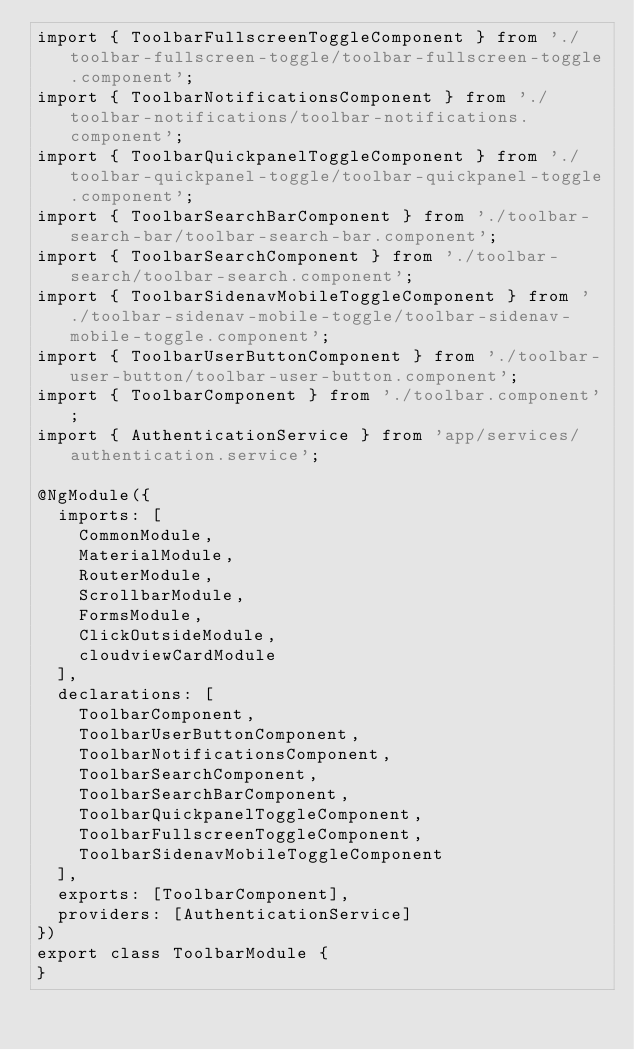Convert code to text. <code><loc_0><loc_0><loc_500><loc_500><_TypeScript_>import { ToolbarFullscreenToggleComponent } from './toolbar-fullscreen-toggle/toolbar-fullscreen-toggle.component';
import { ToolbarNotificationsComponent } from './toolbar-notifications/toolbar-notifications.component';
import { ToolbarQuickpanelToggleComponent } from './toolbar-quickpanel-toggle/toolbar-quickpanel-toggle.component';
import { ToolbarSearchBarComponent } from './toolbar-search-bar/toolbar-search-bar.component';
import { ToolbarSearchComponent } from './toolbar-search/toolbar-search.component';
import { ToolbarSidenavMobileToggleComponent } from './toolbar-sidenav-mobile-toggle/toolbar-sidenav-mobile-toggle.component';
import { ToolbarUserButtonComponent } from './toolbar-user-button/toolbar-user-button.component';
import { ToolbarComponent } from './toolbar.component';
import { AuthenticationService } from 'app/services/authentication.service';

@NgModule({
  imports: [
    CommonModule,
    MaterialModule,
    RouterModule,
    ScrollbarModule,
    FormsModule,
    ClickOutsideModule,
    cloudviewCardModule
  ],
  declarations: [
    ToolbarComponent,
    ToolbarUserButtonComponent,
    ToolbarNotificationsComponent,
    ToolbarSearchComponent,
    ToolbarSearchBarComponent,
    ToolbarQuickpanelToggleComponent,
    ToolbarFullscreenToggleComponent,
    ToolbarSidenavMobileToggleComponent
  ],
  exports: [ToolbarComponent],
  providers: [AuthenticationService]
})
export class ToolbarModule {
}
</code> 